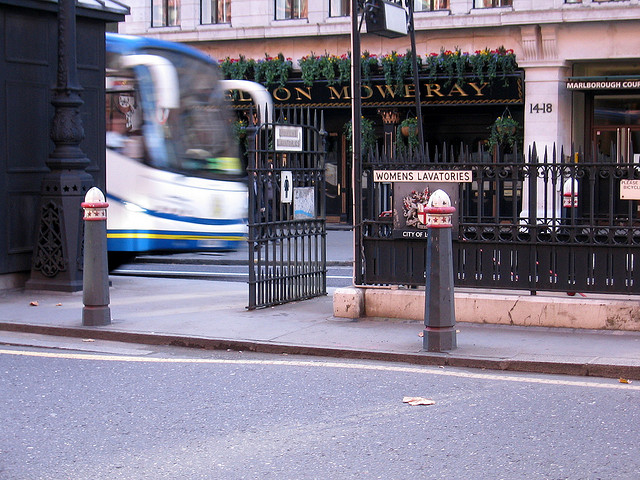Identify the text displayed in this image. WOMENS LAVATORIES 14-18 MARLBOROUGH Of CITY 